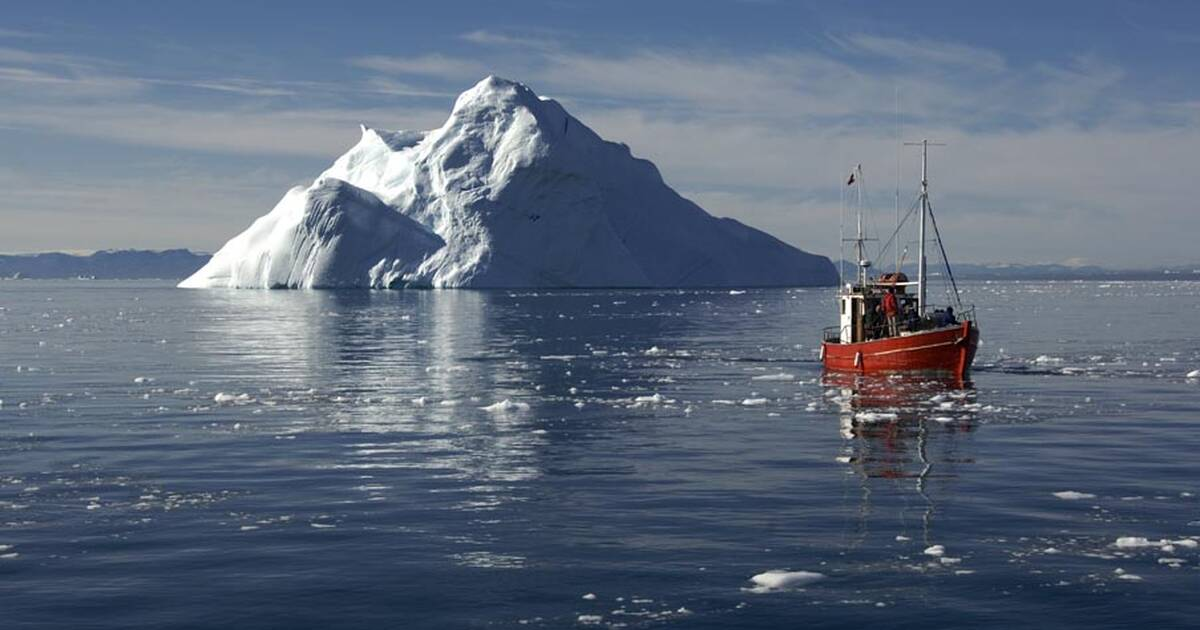Imagine the ecosystem beneath the iceberg. Describe it in great detail. Beneath the iceberg in the Ilulissat Icefjord lies a hidden world teeming with life and shaped by the unique conditions of the Arctic waters. The temperature here is frigid, yet the marine ecosystem thrives in this extreme environment. The iceberg itself extends deep into the ocean, creating a complex, vertical habitat.

At the iceberg's base, the seafloor is rocky and uneven, providing niches for various benthic organisms. Starfish and sea urchins cling to the rocks, while sponges sway gently with the currents. The cold, nutrient-rich water supports dense blooms of phytoplankton, forming the foundation of the food web.

Schools of Arctic cod dart between the shadows of the ice, their silvery bodies reflecting the dim light filtering through the iceberg. Larger predators, such as seals and sometimes even narwhals, navigate these waters in search of prey. The ice's undersides serve as a grazing ground for krill and amphipods, which feed on the algae growing in the dim twilight zone.

Delicate comb jellies drift gracefully, their bioluminescent bodies glowing faintly. Occasionally, the eerie calls of beluga whales resonate through the icy waters, adding an otherworldly soundtrack to this hidden realm. The intricate dance of life beneath the iceberg showcases the resilience and adaptability of species in one of the planet's most challenging environments. 